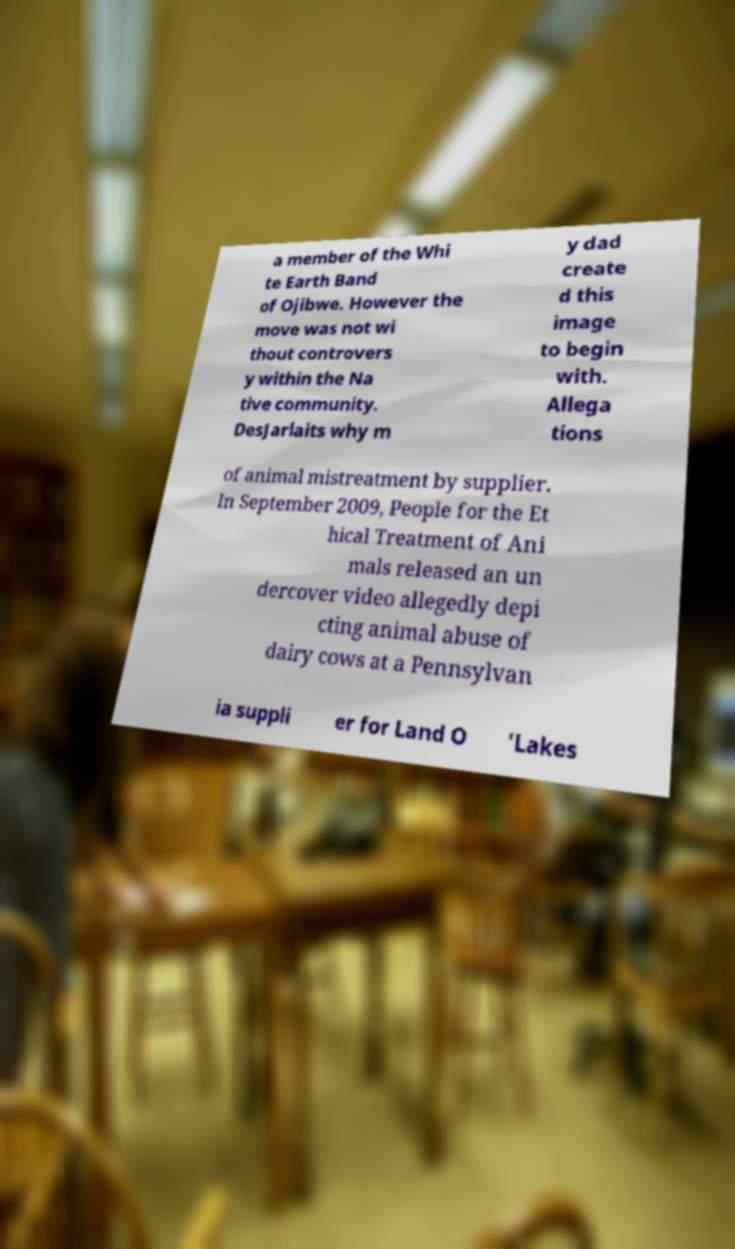Please identify and transcribe the text found in this image. a member of the Whi te Earth Band of Ojibwe. However the move was not wi thout controvers y within the Na tive community. DesJarlaits why m y dad create d this image to begin with. Allega tions of animal mistreatment by supplier. In September 2009, People for the Et hical Treatment of Ani mals released an un dercover video allegedly depi cting animal abuse of dairy cows at a Pennsylvan ia suppli er for Land O ’Lakes 